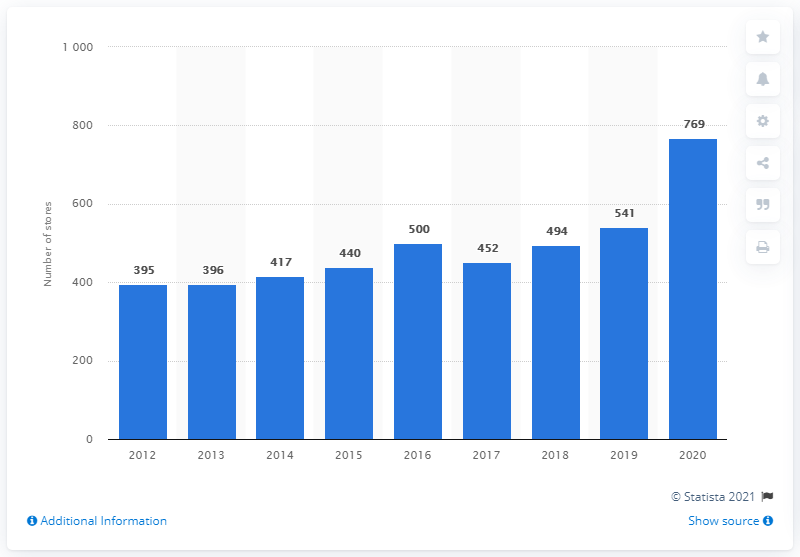Mention a couple of crucial points in this snapshot. As of 2020, Sports Direct had a total of 769 locations in the United Kingdom. 